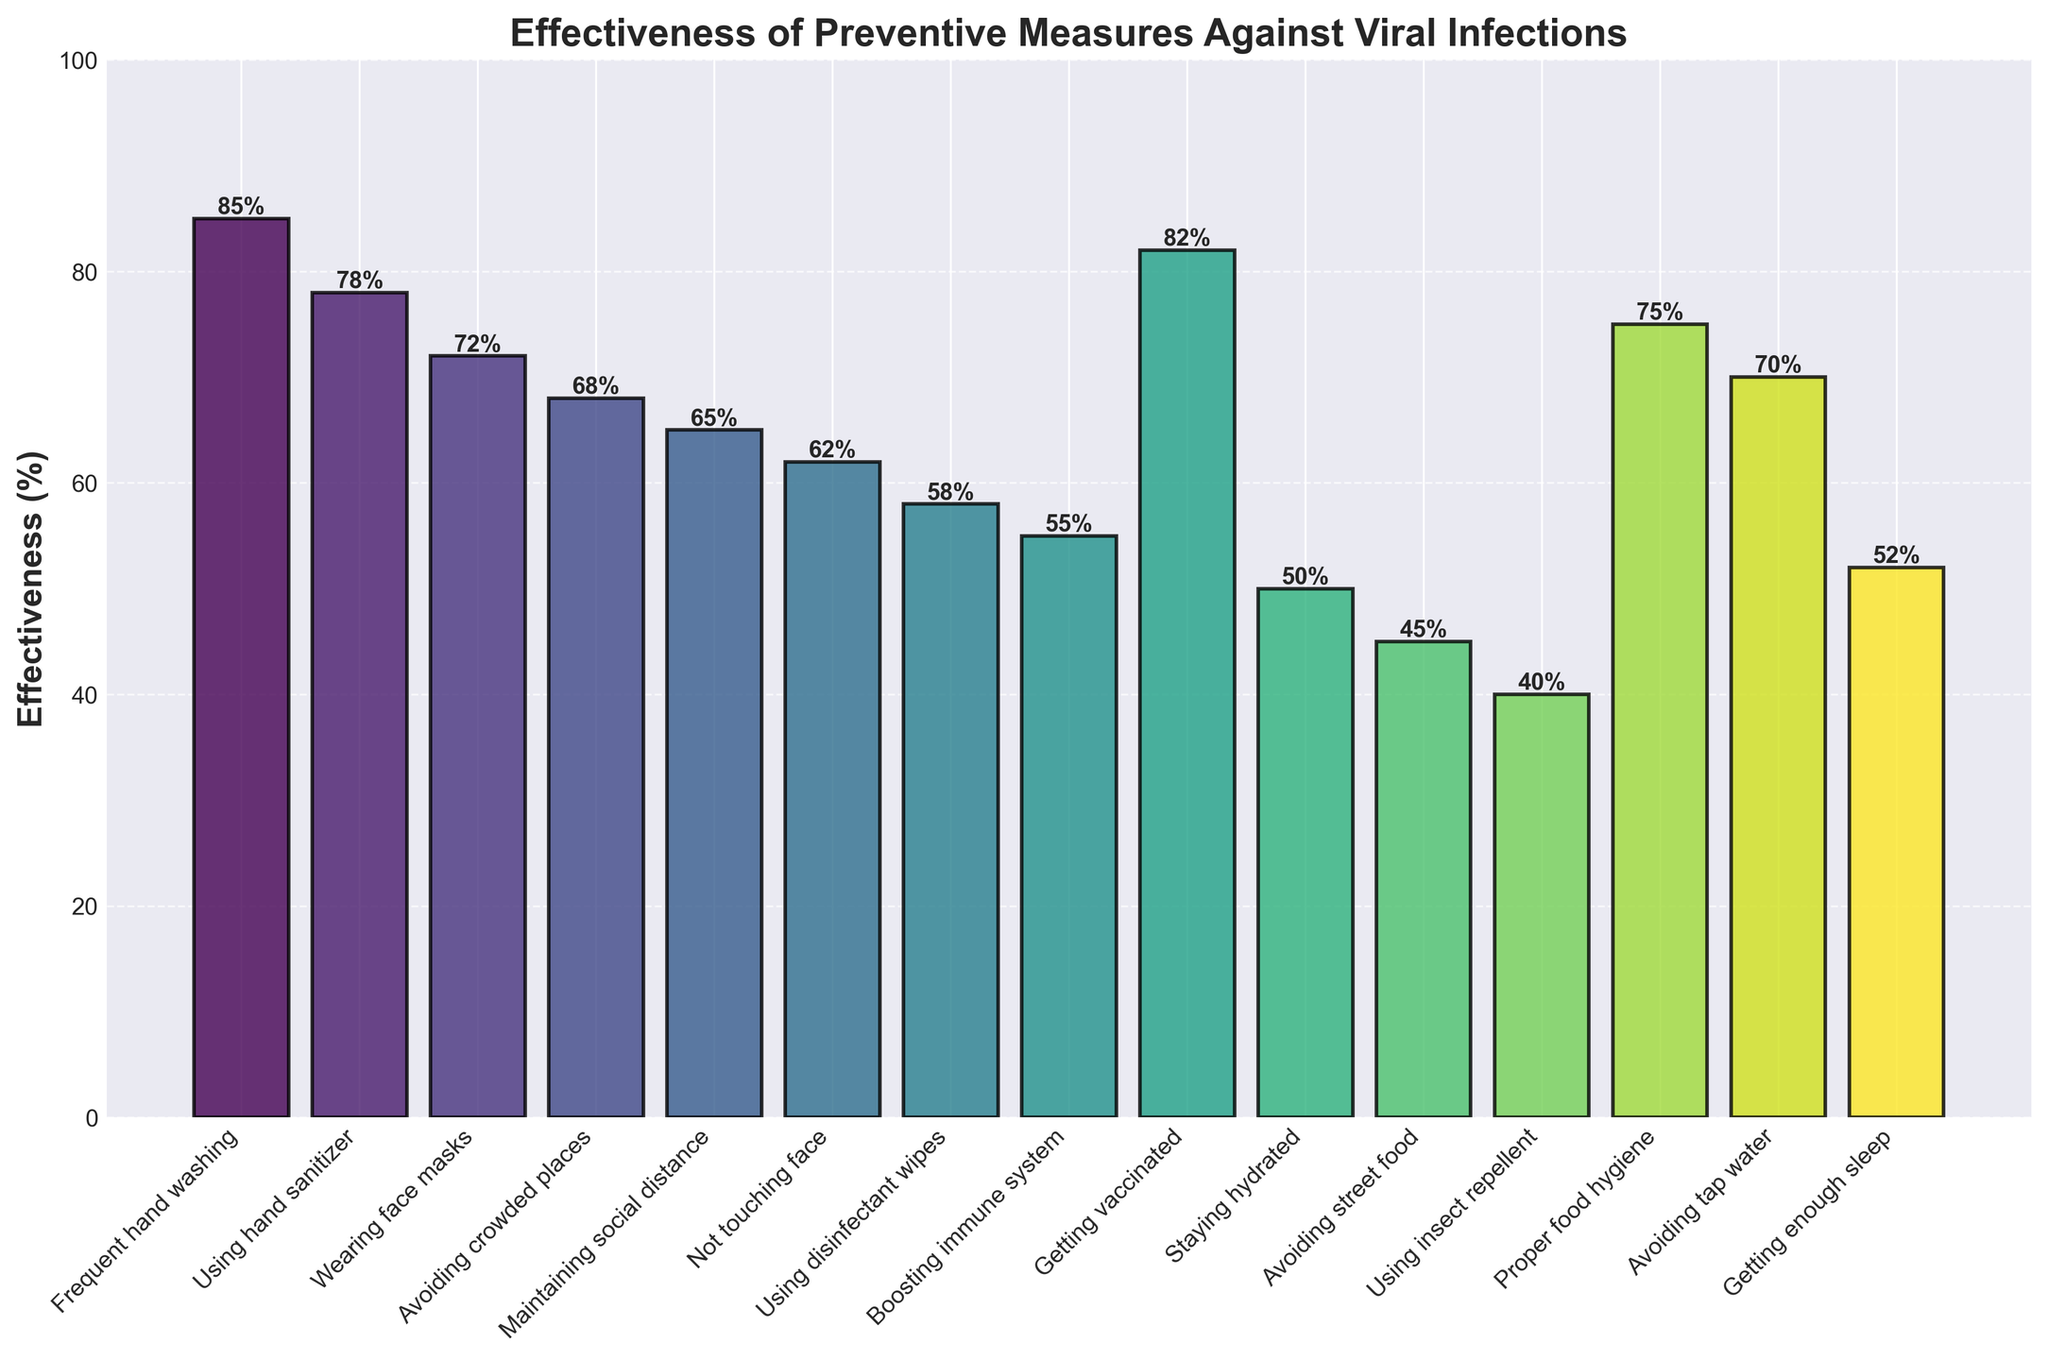what is the most effective preventive measure against viral infections while traveling? The bar chart shows the effectiveness percentages of various preventive measures. By looking at the height of the bars, you can see that "Frequent hand washing" has the highest percentage, followed closely by "Getting vaccinated".
Answer: Frequent hand washing Which measure is more effective: avoiding crowded places or wearing face masks? To compare the effectiveness, we look at the height of the bars. "Wearing face masks" has an effectiveness of 72%, while "Avoiding crowded places" has an effectiveness of 68%. Thus, wearing face masks is slightly more effective.
Answer: Wearing face masks What is the average effectiveness of the top three preventive measures? The top three measures by effectiveness are "Frequent hand washing" (85%), "Getting vaccinated" (82%), and "Using hand sanitizer" (78%). To find the average, sum these percentages and divide by three: (85 + 82 + 78) / 3 = 245 / 3 ≈ 81.67.
Answer: 81.67% Which preventive measure has a higher effectiveness: maintaining social distance or not touching face? Compare the heights of the bars corresponding to "Maintaining social distance" (65%) and "Not touching face" (62%). "Maintaining social distance" has a higher effectiveness percentage.
Answer: Maintaining social distance What is the cumulative effectiveness of the measures involving hygiene (Frequent hand washing, Using hand sanitizer, Using disinfectant wipes)? First, identify the effectiveness of each relevant measure: "Frequent hand washing" (85%), "Using hand sanitizer" (78%), and "Using disinfectant wipes" (58%). Sum these values: 85 + 78 + 58 = 221.
Answer: 221% What's the difference in effectiveness between getting enough sleep and boosting the immune system? "Getting enough sleep" has an effectiveness of 52%, while "Boosting immune system" is at 55%. The difference is 55 - 52 = 3.
Answer: 3% What is the least effective preventive measure against viral infections? The measure with the shortest bar represents the least effective preventive measure. "Using insect repellent" has the lowest effectiveness at 40%.
Answer: Using insect repellent How many preventive measures have an effectiveness of 70% or higher? Examine each bar to see which ones meet or exceed 70%. They are: "Frequent hand washing" (85%), "Getting vaccinated" (82%), "Using hand sanitizer" (78%), "Proper food hygiene" (75%), "Wearing face masks" (72%), and "Avoiding tap water" (70%). This makes for a total of 6 measures.
Answer: 6 measures Which has a higher effectiveness: avoiding street food or staying hydrated? Compare the heights of the bars for these measures. "Avoiding street food" has an effectiveness of 45%, while "Staying hydrated" is at 50%. Therefore, staying hydrated is more effective.
Answer: Staying hydrated 